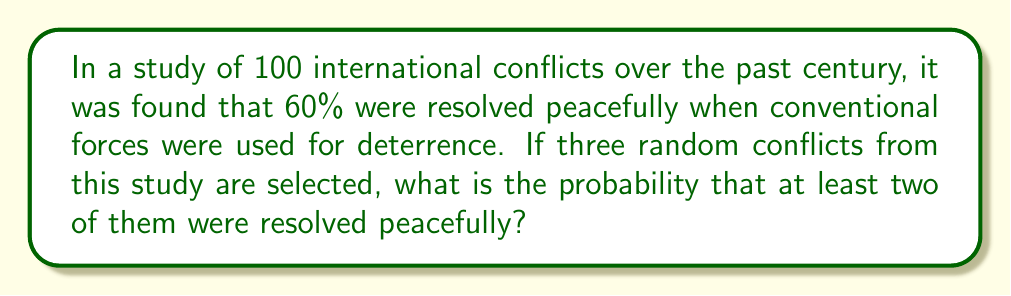Give your solution to this math problem. Let's approach this step-by-step using the binomial probability distribution:

1) Let p be the probability of a peaceful resolution. From the given information, p = 0.60

2) We want to find the probability of at least 2 successes out of 3 trials. This is equivalent to the probability of 2 successes plus the probability of 3 successes.

3) The probability of exactly k successes in n trials is given by the binomial probability formula:

   $$P(X = k) = \binom{n}{k} p^k (1-p)^{n-k}$$

4) For 2 successes out of 3 trials:

   $$P(X = 2) = \binom{3}{2} (0.60)^2 (0.40)^1 = 3 \cdot 0.36 \cdot 0.40 = 0.432$$

5) For 3 successes out of 3 trials:

   $$P(X = 3) = \binom{3}{3} (0.60)^3 (0.40)^0 = 1 \cdot 0.216 \cdot 1 = 0.216$$

6) The probability of at least 2 successes is the sum of these probabilities:

   $$P(X \geq 2) = P(X = 2) + P(X = 3) = 0.432 + 0.216 = 0.648$$

Therefore, the probability of at least two out of three randomly selected conflicts being resolved peacefully is 0.648 or 64.8%.
Answer: 0.648 